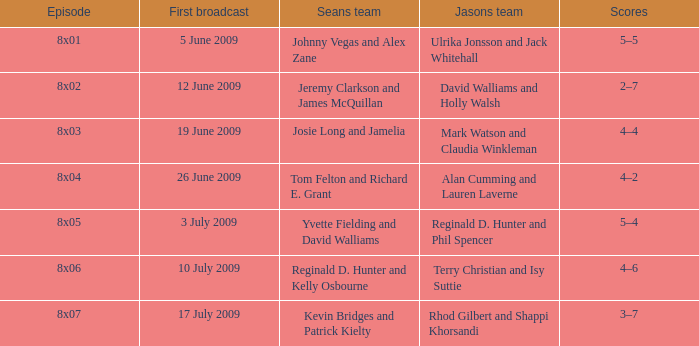In the episode where sean's team consisted of reginald d. hunter and kelly osbourne, who was part of jason's team? Terry Christian and Isy Suttie. 